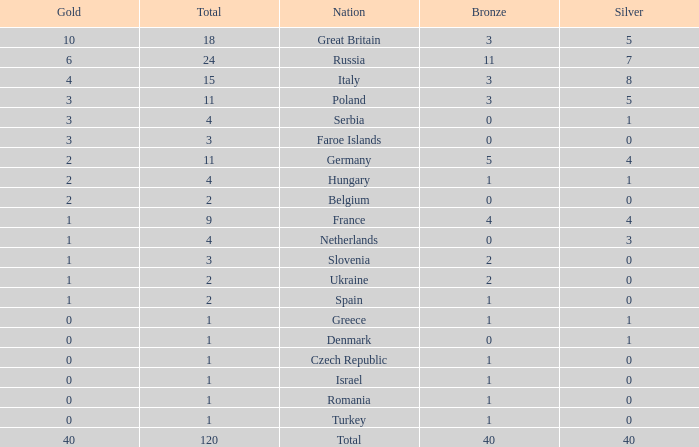What is the average Gold entry for the Netherlands that also has a Bronze entry that is greater than 0? None. 